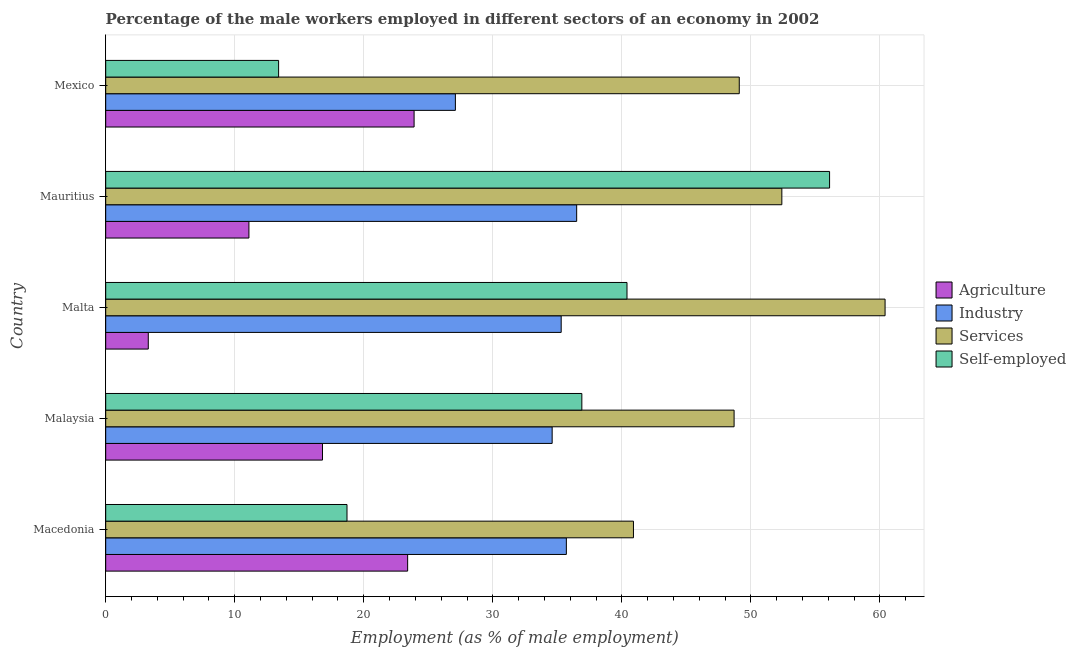How many groups of bars are there?
Your response must be concise. 5. Are the number of bars per tick equal to the number of legend labels?
Ensure brevity in your answer.  Yes. Are the number of bars on each tick of the Y-axis equal?
Your answer should be compact. Yes. How many bars are there on the 5th tick from the top?
Your answer should be very brief. 4. In how many cases, is the number of bars for a given country not equal to the number of legend labels?
Your response must be concise. 0. What is the percentage of male workers in agriculture in Macedonia?
Ensure brevity in your answer.  23.4. Across all countries, what is the maximum percentage of male workers in industry?
Provide a short and direct response. 36.5. Across all countries, what is the minimum percentage of male workers in industry?
Provide a short and direct response. 27.1. In which country was the percentage of male workers in agriculture maximum?
Your response must be concise. Mexico. What is the total percentage of male workers in services in the graph?
Offer a very short reply. 251.5. What is the difference between the percentage of male workers in agriculture in Mexico and the percentage of self employed male workers in Mauritius?
Provide a succinct answer. -32.2. What is the average percentage of male workers in industry per country?
Offer a terse response. 33.84. What is the difference between the percentage of male workers in agriculture and percentage of male workers in services in Malta?
Offer a very short reply. -57.1. What is the ratio of the percentage of male workers in services in Macedonia to that in Malaysia?
Keep it short and to the point. 0.84. Is the percentage of male workers in agriculture in Macedonia less than that in Mexico?
Provide a succinct answer. Yes. Is the difference between the percentage of self employed male workers in Malaysia and Malta greater than the difference between the percentage of male workers in services in Malaysia and Malta?
Your response must be concise. Yes. What is the difference between the highest and the second highest percentage of male workers in agriculture?
Provide a short and direct response. 0.5. What is the difference between the highest and the lowest percentage of self employed male workers?
Your answer should be compact. 42.7. In how many countries, is the percentage of male workers in agriculture greater than the average percentage of male workers in agriculture taken over all countries?
Offer a terse response. 3. Is the sum of the percentage of male workers in agriculture in Macedonia and Mexico greater than the maximum percentage of self employed male workers across all countries?
Your answer should be very brief. No. What does the 2nd bar from the top in Malta represents?
Your response must be concise. Services. What does the 1st bar from the bottom in Mauritius represents?
Make the answer very short. Agriculture. Are all the bars in the graph horizontal?
Give a very brief answer. Yes. Does the graph contain any zero values?
Ensure brevity in your answer.  No. Where does the legend appear in the graph?
Offer a very short reply. Center right. How are the legend labels stacked?
Your answer should be compact. Vertical. What is the title of the graph?
Your response must be concise. Percentage of the male workers employed in different sectors of an economy in 2002. What is the label or title of the X-axis?
Your response must be concise. Employment (as % of male employment). What is the label or title of the Y-axis?
Offer a terse response. Country. What is the Employment (as % of male employment) of Agriculture in Macedonia?
Provide a succinct answer. 23.4. What is the Employment (as % of male employment) in Industry in Macedonia?
Give a very brief answer. 35.7. What is the Employment (as % of male employment) of Services in Macedonia?
Make the answer very short. 40.9. What is the Employment (as % of male employment) in Self-employed in Macedonia?
Provide a succinct answer. 18.7. What is the Employment (as % of male employment) in Agriculture in Malaysia?
Your response must be concise. 16.8. What is the Employment (as % of male employment) of Industry in Malaysia?
Make the answer very short. 34.6. What is the Employment (as % of male employment) of Services in Malaysia?
Keep it short and to the point. 48.7. What is the Employment (as % of male employment) of Self-employed in Malaysia?
Ensure brevity in your answer.  36.9. What is the Employment (as % of male employment) of Agriculture in Malta?
Keep it short and to the point. 3.3. What is the Employment (as % of male employment) of Industry in Malta?
Make the answer very short. 35.3. What is the Employment (as % of male employment) in Services in Malta?
Offer a terse response. 60.4. What is the Employment (as % of male employment) of Self-employed in Malta?
Offer a very short reply. 40.4. What is the Employment (as % of male employment) in Agriculture in Mauritius?
Keep it short and to the point. 11.1. What is the Employment (as % of male employment) in Industry in Mauritius?
Your response must be concise. 36.5. What is the Employment (as % of male employment) in Services in Mauritius?
Make the answer very short. 52.4. What is the Employment (as % of male employment) in Self-employed in Mauritius?
Make the answer very short. 56.1. What is the Employment (as % of male employment) in Agriculture in Mexico?
Keep it short and to the point. 23.9. What is the Employment (as % of male employment) in Industry in Mexico?
Provide a short and direct response. 27.1. What is the Employment (as % of male employment) in Services in Mexico?
Ensure brevity in your answer.  49.1. What is the Employment (as % of male employment) of Self-employed in Mexico?
Give a very brief answer. 13.4. Across all countries, what is the maximum Employment (as % of male employment) of Agriculture?
Make the answer very short. 23.9. Across all countries, what is the maximum Employment (as % of male employment) of Industry?
Your answer should be compact. 36.5. Across all countries, what is the maximum Employment (as % of male employment) in Services?
Offer a very short reply. 60.4. Across all countries, what is the maximum Employment (as % of male employment) of Self-employed?
Make the answer very short. 56.1. Across all countries, what is the minimum Employment (as % of male employment) of Agriculture?
Provide a short and direct response. 3.3. Across all countries, what is the minimum Employment (as % of male employment) of Industry?
Your answer should be very brief. 27.1. Across all countries, what is the minimum Employment (as % of male employment) in Services?
Provide a succinct answer. 40.9. Across all countries, what is the minimum Employment (as % of male employment) in Self-employed?
Provide a short and direct response. 13.4. What is the total Employment (as % of male employment) of Agriculture in the graph?
Make the answer very short. 78.5. What is the total Employment (as % of male employment) in Industry in the graph?
Keep it short and to the point. 169.2. What is the total Employment (as % of male employment) in Services in the graph?
Your response must be concise. 251.5. What is the total Employment (as % of male employment) of Self-employed in the graph?
Your response must be concise. 165.5. What is the difference between the Employment (as % of male employment) in Agriculture in Macedonia and that in Malaysia?
Ensure brevity in your answer.  6.6. What is the difference between the Employment (as % of male employment) in Industry in Macedonia and that in Malaysia?
Make the answer very short. 1.1. What is the difference between the Employment (as % of male employment) of Services in Macedonia and that in Malaysia?
Ensure brevity in your answer.  -7.8. What is the difference between the Employment (as % of male employment) of Self-employed in Macedonia and that in Malaysia?
Ensure brevity in your answer.  -18.2. What is the difference between the Employment (as % of male employment) of Agriculture in Macedonia and that in Malta?
Your answer should be very brief. 20.1. What is the difference between the Employment (as % of male employment) of Industry in Macedonia and that in Malta?
Offer a very short reply. 0.4. What is the difference between the Employment (as % of male employment) of Services in Macedonia and that in Malta?
Your answer should be compact. -19.5. What is the difference between the Employment (as % of male employment) of Self-employed in Macedonia and that in Malta?
Provide a short and direct response. -21.7. What is the difference between the Employment (as % of male employment) in Industry in Macedonia and that in Mauritius?
Your answer should be very brief. -0.8. What is the difference between the Employment (as % of male employment) of Services in Macedonia and that in Mauritius?
Offer a very short reply. -11.5. What is the difference between the Employment (as % of male employment) in Self-employed in Macedonia and that in Mauritius?
Ensure brevity in your answer.  -37.4. What is the difference between the Employment (as % of male employment) in Agriculture in Macedonia and that in Mexico?
Your answer should be very brief. -0.5. What is the difference between the Employment (as % of male employment) in Industry in Macedonia and that in Mexico?
Provide a succinct answer. 8.6. What is the difference between the Employment (as % of male employment) in Services in Macedonia and that in Mexico?
Ensure brevity in your answer.  -8.2. What is the difference between the Employment (as % of male employment) in Self-employed in Macedonia and that in Mexico?
Offer a very short reply. 5.3. What is the difference between the Employment (as % of male employment) in Agriculture in Malaysia and that in Malta?
Provide a short and direct response. 13.5. What is the difference between the Employment (as % of male employment) of Industry in Malaysia and that in Malta?
Your response must be concise. -0.7. What is the difference between the Employment (as % of male employment) in Services in Malaysia and that in Malta?
Your answer should be compact. -11.7. What is the difference between the Employment (as % of male employment) in Agriculture in Malaysia and that in Mauritius?
Your answer should be compact. 5.7. What is the difference between the Employment (as % of male employment) in Services in Malaysia and that in Mauritius?
Your response must be concise. -3.7. What is the difference between the Employment (as % of male employment) of Self-employed in Malaysia and that in Mauritius?
Ensure brevity in your answer.  -19.2. What is the difference between the Employment (as % of male employment) in Agriculture in Malaysia and that in Mexico?
Your answer should be very brief. -7.1. What is the difference between the Employment (as % of male employment) of Industry in Malaysia and that in Mexico?
Ensure brevity in your answer.  7.5. What is the difference between the Employment (as % of male employment) of Services in Malaysia and that in Mexico?
Offer a terse response. -0.4. What is the difference between the Employment (as % of male employment) of Self-employed in Malaysia and that in Mexico?
Your answer should be very brief. 23.5. What is the difference between the Employment (as % of male employment) in Self-employed in Malta and that in Mauritius?
Provide a succinct answer. -15.7. What is the difference between the Employment (as % of male employment) of Agriculture in Malta and that in Mexico?
Give a very brief answer. -20.6. What is the difference between the Employment (as % of male employment) of Industry in Malta and that in Mexico?
Make the answer very short. 8.2. What is the difference between the Employment (as % of male employment) of Agriculture in Mauritius and that in Mexico?
Keep it short and to the point. -12.8. What is the difference between the Employment (as % of male employment) in Services in Mauritius and that in Mexico?
Offer a very short reply. 3.3. What is the difference between the Employment (as % of male employment) in Self-employed in Mauritius and that in Mexico?
Make the answer very short. 42.7. What is the difference between the Employment (as % of male employment) in Agriculture in Macedonia and the Employment (as % of male employment) in Industry in Malaysia?
Offer a terse response. -11.2. What is the difference between the Employment (as % of male employment) of Agriculture in Macedonia and the Employment (as % of male employment) of Services in Malaysia?
Your answer should be compact. -25.3. What is the difference between the Employment (as % of male employment) in Agriculture in Macedonia and the Employment (as % of male employment) in Industry in Malta?
Provide a succinct answer. -11.9. What is the difference between the Employment (as % of male employment) in Agriculture in Macedonia and the Employment (as % of male employment) in Services in Malta?
Your answer should be very brief. -37. What is the difference between the Employment (as % of male employment) of Agriculture in Macedonia and the Employment (as % of male employment) of Self-employed in Malta?
Offer a terse response. -17. What is the difference between the Employment (as % of male employment) of Industry in Macedonia and the Employment (as % of male employment) of Services in Malta?
Your response must be concise. -24.7. What is the difference between the Employment (as % of male employment) in Services in Macedonia and the Employment (as % of male employment) in Self-employed in Malta?
Provide a short and direct response. 0.5. What is the difference between the Employment (as % of male employment) of Agriculture in Macedonia and the Employment (as % of male employment) of Industry in Mauritius?
Offer a terse response. -13.1. What is the difference between the Employment (as % of male employment) in Agriculture in Macedonia and the Employment (as % of male employment) in Self-employed in Mauritius?
Keep it short and to the point. -32.7. What is the difference between the Employment (as % of male employment) of Industry in Macedonia and the Employment (as % of male employment) of Services in Mauritius?
Offer a very short reply. -16.7. What is the difference between the Employment (as % of male employment) in Industry in Macedonia and the Employment (as % of male employment) in Self-employed in Mauritius?
Your answer should be compact. -20.4. What is the difference between the Employment (as % of male employment) of Services in Macedonia and the Employment (as % of male employment) of Self-employed in Mauritius?
Provide a short and direct response. -15.2. What is the difference between the Employment (as % of male employment) in Agriculture in Macedonia and the Employment (as % of male employment) in Services in Mexico?
Your answer should be very brief. -25.7. What is the difference between the Employment (as % of male employment) in Industry in Macedonia and the Employment (as % of male employment) in Services in Mexico?
Offer a very short reply. -13.4. What is the difference between the Employment (as % of male employment) in Industry in Macedonia and the Employment (as % of male employment) in Self-employed in Mexico?
Keep it short and to the point. 22.3. What is the difference between the Employment (as % of male employment) of Agriculture in Malaysia and the Employment (as % of male employment) of Industry in Malta?
Your answer should be compact. -18.5. What is the difference between the Employment (as % of male employment) of Agriculture in Malaysia and the Employment (as % of male employment) of Services in Malta?
Give a very brief answer. -43.6. What is the difference between the Employment (as % of male employment) in Agriculture in Malaysia and the Employment (as % of male employment) in Self-employed in Malta?
Your response must be concise. -23.6. What is the difference between the Employment (as % of male employment) of Industry in Malaysia and the Employment (as % of male employment) of Services in Malta?
Offer a terse response. -25.8. What is the difference between the Employment (as % of male employment) of Industry in Malaysia and the Employment (as % of male employment) of Self-employed in Malta?
Give a very brief answer. -5.8. What is the difference between the Employment (as % of male employment) in Services in Malaysia and the Employment (as % of male employment) in Self-employed in Malta?
Provide a succinct answer. 8.3. What is the difference between the Employment (as % of male employment) in Agriculture in Malaysia and the Employment (as % of male employment) in Industry in Mauritius?
Provide a short and direct response. -19.7. What is the difference between the Employment (as % of male employment) of Agriculture in Malaysia and the Employment (as % of male employment) of Services in Mauritius?
Provide a succinct answer. -35.6. What is the difference between the Employment (as % of male employment) of Agriculture in Malaysia and the Employment (as % of male employment) of Self-employed in Mauritius?
Your response must be concise. -39.3. What is the difference between the Employment (as % of male employment) in Industry in Malaysia and the Employment (as % of male employment) in Services in Mauritius?
Provide a short and direct response. -17.8. What is the difference between the Employment (as % of male employment) in Industry in Malaysia and the Employment (as % of male employment) in Self-employed in Mauritius?
Your response must be concise. -21.5. What is the difference between the Employment (as % of male employment) in Agriculture in Malaysia and the Employment (as % of male employment) in Services in Mexico?
Offer a terse response. -32.3. What is the difference between the Employment (as % of male employment) in Agriculture in Malaysia and the Employment (as % of male employment) in Self-employed in Mexico?
Provide a short and direct response. 3.4. What is the difference between the Employment (as % of male employment) of Industry in Malaysia and the Employment (as % of male employment) of Services in Mexico?
Provide a succinct answer. -14.5. What is the difference between the Employment (as % of male employment) in Industry in Malaysia and the Employment (as % of male employment) in Self-employed in Mexico?
Provide a short and direct response. 21.2. What is the difference between the Employment (as % of male employment) in Services in Malaysia and the Employment (as % of male employment) in Self-employed in Mexico?
Your response must be concise. 35.3. What is the difference between the Employment (as % of male employment) in Agriculture in Malta and the Employment (as % of male employment) in Industry in Mauritius?
Your answer should be very brief. -33.2. What is the difference between the Employment (as % of male employment) in Agriculture in Malta and the Employment (as % of male employment) in Services in Mauritius?
Give a very brief answer. -49.1. What is the difference between the Employment (as % of male employment) in Agriculture in Malta and the Employment (as % of male employment) in Self-employed in Mauritius?
Offer a terse response. -52.8. What is the difference between the Employment (as % of male employment) of Industry in Malta and the Employment (as % of male employment) of Services in Mauritius?
Your response must be concise. -17.1. What is the difference between the Employment (as % of male employment) of Industry in Malta and the Employment (as % of male employment) of Self-employed in Mauritius?
Make the answer very short. -20.8. What is the difference between the Employment (as % of male employment) in Services in Malta and the Employment (as % of male employment) in Self-employed in Mauritius?
Make the answer very short. 4.3. What is the difference between the Employment (as % of male employment) of Agriculture in Malta and the Employment (as % of male employment) of Industry in Mexico?
Your answer should be compact. -23.8. What is the difference between the Employment (as % of male employment) in Agriculture in Malta and the Employment (as % of male employment) in Services in Mexico?
Provide a succinct answer. -45.8. What is the difference between the Employment (as % of male employment) in Industry in Malta and the Employment (as % of male employment) in Services in Mexico?
Offer a very short reply. -13.8. What is the difference between the Employment (as % of male employment) of Industry in Malta and the Employment (as % of male employment) of Self-employed in Mexico?
Ensure brevity in your answer.  21.9. What is the difference between the Employment (as % of male employment) of Services in Malta and the Employment (as % of male employment) of Self-employed in Mexico?
Your answer should be compact. 47. What is the difference between the Employment (as % of male employment) in Agriculture in Mauritius and the Employment (as % of male employment) in Industry in Mexico?
Offer a terse response. -16. What is the difference between the Employment (as % of male employment) of Agriculture in Mauritius and the Employment (as % of male employment) of Services in Mexico?
Make the answer very short. -38. What is the difference between the Employment (as % of male employment) in Agriculture in Mauritius and the Employment (as % of male employment) in Self-employed in Mexico?
Provide a succinct answer. -2.3. What is the difference between the Employment (as % of male employment) of Industry in Mauritius and the Employment (as % of male employment) of Services in Mexico?
Make the answer very short. -12.6. What is the difference between the Employment (as % of male employment) of Industry in Mauritius and the Employment (as % of male employment) of Self-employed in Mexico?
Your response must be concise. 23.1. What is the difference between the Employment (as % of male employment) in Services in Mauritius and the Employment (as % of male employment) in Self-employed in Mexico?
Your answer should be very brief. 39. What is the average Employment (as % of male employment) of Industry per country?
Give a very brief answer. 33.84. What is the average Employment (as % of male employment) in Services per country?
Keep it short and to the point. 50.3. What is the average Employment (as % of male employment) of Self-employed per country?
Provide a short and direct response. 33.1. What is the difference between the Employment (as % of male employment) of Agriculture and Employment (as % of male employment) of Industry in Macedonia?
Offer a very short reply. -12.3. What is the difference between the Employment (as % of male employment) of Agriculture and Employment (as % of male employment) of Services in Macedonia?
Offer a terse response. -17.5. What is the difference between the Employment (as % of male employment) in Industry and Employment (as % of male employment) in Services in Macedonia?
Your response must be concise. -5.2. What is the difference between the Employment (as % of male employment) in Services and Employment (as % of male employment) in Self-employed in Macedonia?
Offer a very short reply. 22.2. What is the difference between the Employment (as % of male employment) of Agriculture and Employment (as % of male employment) of Industry in Malaysia?
Your answer should be compact. -17.8. What is the difference between the Employment (as % of male employment) in Agriculture and Employment (as % of male employment) in Services in Malaysia?
Provide a succinct answer. -31.9. What is the difference between the Employment (as % of male employment) of Agriculture and Employment (as % of male employment) of Self-employed in Malaysia?
Provide a succinct answer. -20.1. What is the difference between the Employment (as % of male employment) of Industry and Employment (as % of male employment) of Services in Malaysia?
Provide a short and direct response. -14.1. What is the difference between the Employment (as % of male employment) in Services and Employment (as % of male employment) in Self-employed in Malaysia?
Make the answer very short. 11.8. What is the difference between the Employment (as % of male employment) of Agriculture and Employment (as % of male employment) of Industry in Malta?
Offer a terse response. -32. What is the difference between the Employment (as % of male employment) of Agriculture and Employment (as % of male employment) of Services in Malta?
Offer a terse response. -57.1. What is the difference between the Employment (as % of male employment) of Agriculture and Employment (as % of male employment) of Self-employed in Malta?
Your answer should be compact. -37.1. What is the difference between the Employment (as % of male employment) of Industry and Employment (as % of male employment) of Services in Malta?
Make the answer very short. -25.1. What is the difference between the Employment (as % of male employment) in Agriculture and Employment (as % of male employment) in Industry in Mauritius?
Offer a terse response. -25.4. What is the difference between the Employment (as % of male employment) of Agriculture and Employment (as % of male employment) of Services in Mauritius?
Your answer should be very brief. -41.3. What is the difference between the Employment (as % of male employment) of Agriculture and Employment (as % of male employment) of Self-employed in Mauritius?
Provide a short and direct response. -45. What is the difference between the Employment (as % of male employment) in Industry and Employment (as % of male employment) in Services in Mauritius?
Ensure brevity in your answer.  -15.9. What is the difference between the Employment (as % of male employment) in Industry and Employment (as % of male employment) in Self-employed in Mauritius?
Provide a short and direct response. -19.6. What is the difference between the Employment (as % of male employment) of Services and Employment (as % of male employment) of Self-employed in Mauritius?
Make the answer very short. -3.7. What is the difference between the Employment (as % of male employment) of Agriculture and Employment (as % of male employment) of Services in Mexico?
Your response must be concise. -25.2. What is the difference between the Employment (as % of male employment) in Agriculture and Employment (as % of male employment) in Self-employed in Mexico?
Make the answer very short. 10.5. What is the difference between the Employment (as % of male employment) of Industry and Employment (as % of male employment) of Services in Mexico?
Make the answer very short. -22. What is the difference between the Employment (as % of male employment) in Industry and Employment (as % of male employment) in Self-employed in Mexico?
Your answer should be very brief. 13.7. What is the difference between the Employment (as % of male employment) in Services and Employment (as % of male employment) in Self-employed in Mexico?
Offer a terse response. 35.7. What is the ratio of the Employment (as % of male employment) in Agriculture in Macedonia to that in Malaysia?
Your answer should be very brief. 1.39. What is the ratio of the Employment (as % of male employment) of Industry in Macedonia to that in Malaysia?
Provide a succinct answer. 1.03. What is the ratio of the Employment (as % of male employment) in Services in Macedonia to that in Malaysia?
Provide a short and direct response. 0.84. What is the ratio of the Employment (as % of male employment) of Self-employed in Macedonia to that in Malaysia?
Provide a short and direct response. 0.51. What is the ratio of the Employment (as % of male employment) of Agriculture in Macedonia to that in Malta?
Your answer should be compact. 7.09. What is the ratio of the Employment (as % of male employment) in Industry in Macedonia to that in Malta?
Ensure brevity in your answer.  1.01. What is the ratio of the Employment (as % of male employment) in Services in Macedonia to that in Malta?
Your response must be concise. 0.68. What is the ratio of the Employment (as % of male employment) in Self-employed in Macedonia to that in Malta?
Your answer should be compact. 0.46. What is the ratio of the Employment (as % of male employment) in Agriculture in Macedonia to that in Mauritius?
Offer a very short reply. 2.11. What is the ratio of the Employment (as % of male employment) of Industry in Macedonia to that in Mauritius?
Provide a short and direct response. 0.98. What is the ratio of the Employment (as % of male employment) in Services in Macedonia to that in Mauritius?
Your response must be concise. 0.78. What is the ratio of the Employment (as % of male employment) in Agriculture in Macedonia to that in Mexico?
Make the answer very short. 0.98. What is the ratio of the Employment (as % of male employment) of Industry in Macedonia to that in Mexico?
Keep it short and to the point. 1.32. What is the ratio of the Employment (as % of male employment) of Services in Macedonia to that in Mexico?
Keep it short and to the point. 0.83. What is the ratio of the Employment (as % of male employment) of Self-employed in Macedonia to that in Mexico?
Make the answer very short. 1.4. What is the ratio of the Employment (as % of male employment) of Agriculture in Malaysia to that in Malta?
Your answer should be compact. 5.09. What is the ratio of the Employment (as % of male employment) in Industry in Malaysia to that in Malta?
Provide a short and direct response. 0.98. What is the ratio of the Employment (as % of male employment) of Services in Malaysia to that in Malta?
Give a very brief answer. 0.81. What is the ratio of the Employment (as % of male employment) of Self-employed in Malaysia to that in Malta?
Ensure brevity in your answer.  0.91. What is the ratio of the Employment (as % of male employment) in Agriculture in Malaysia to that in Mauritius?
Your response must be concise. 1.51. What is the ratio of the Employment (as % of male employment) in Industry in Malaysia to that in Mauritius?
Offer a very short reply. 0.95. What is the ratio of the Employment (as % of male employment) in Services in Malaysia to that in Mauritius?
Offer a terse response. 0.93. What is the ratio of the Employment (as % of male employment) in Self-employed in Malaysia to that in Mauritius?
Provide a short and direct response. 0.66. What is the ratio of the Employment (as % of male employment) in Agriculture in Malaysia to that in Mexico?
Provide a short and direct response. 0.7. What is the ratio of the Employment (as % of male employment) of Industry in Malaysia to that in Mexico?
Offer a terse response. 1.28. What is the ratio of the Employment (as % of male employment) in Self-employed in Malaysia to that in Mexico?
Ensure brevity in your answer.  2.75. What is the ratio of the Employment (as % of male employment) of Agriculture in Malta to that in Mauritius?
Provide a short and direct response. 0.3. What is the ratio of the Employment (as % of male employment) in Industry in Malta to that in Mauritius?
Ensure brevity in your answer.  0.97. What is the ratio of the Employment (as % of male employment) in Services in Malta to that in Mauritius?
Provide a short and direct response. 1.15. What is the ratio of the Employment (as % of male employment) of Self-employed in Malta to that in Mauritius?
Ensure brevity in your answer.  0.72. What is the ratio of the Employment (as % of male employment) in Agriculture in Malta to that in Mexico?
Your answer should be compact. 0.14. What is the ratio of the Employment (as % of male employment) of Industry in Malta to that in Mexico?
Your answer should be compact. 1.3. What is the ratio of the Employment (as % of male employment) of Services in Malta to that in Mexico?
Your answer should be compact. 1.23. What is the ratio of the Employment (as % of male employment) of Self-employed in Malta to that in Mexico?
Your answer should be very brief. 3.01. What is the ratio of the Employment (as % of male employment) in Agriculture in Mauritius to that in Mexico?
Your response must be concise. 0.46. What is the ratio of the Employment (as % of male employment) of Industry in Mauritius to that in Mexico?
Keep it short and to the point. 1.35. What is the ratio of the Employment (as % of male employment) of Services in Mauritius to that in Mexico?
Your answer should be compact. 1.07. What is the ratio of the Employment (as % of male employment) of Self-employed in Mauritius to that in Mexico?
Your answer should be very brief. 4.19. What is the difference between the highest and the second highest Employment (as % of male employment) of Agriculture?
Provide a succinct answer. 0.5. What is the difference between the highest and the second highest Employment (as % of male employment) in Services?
Offer a very short reply. 8. What is the difference between the highest and the second highest Employment (as % of male employment) of Self-employed?
Make the answer very short. 15.7. What is the difference between the highest and the lowest Employment (as % of male employment) in Agriculture?
Offer a terse response. 20.6. What is the difference between the highest and the lowest Employment (as % of male employment) of Industry?
Give a very brief answer. 9.4. What is the difference between the highest and the lowest Employment (as % of male employment) in Services?
Keep it short and to the point. 19.5. What is the difference between the highest and the lowest Employment (as % of male employment) of Self-employed?
Keep it short and to the point. 42.7. 